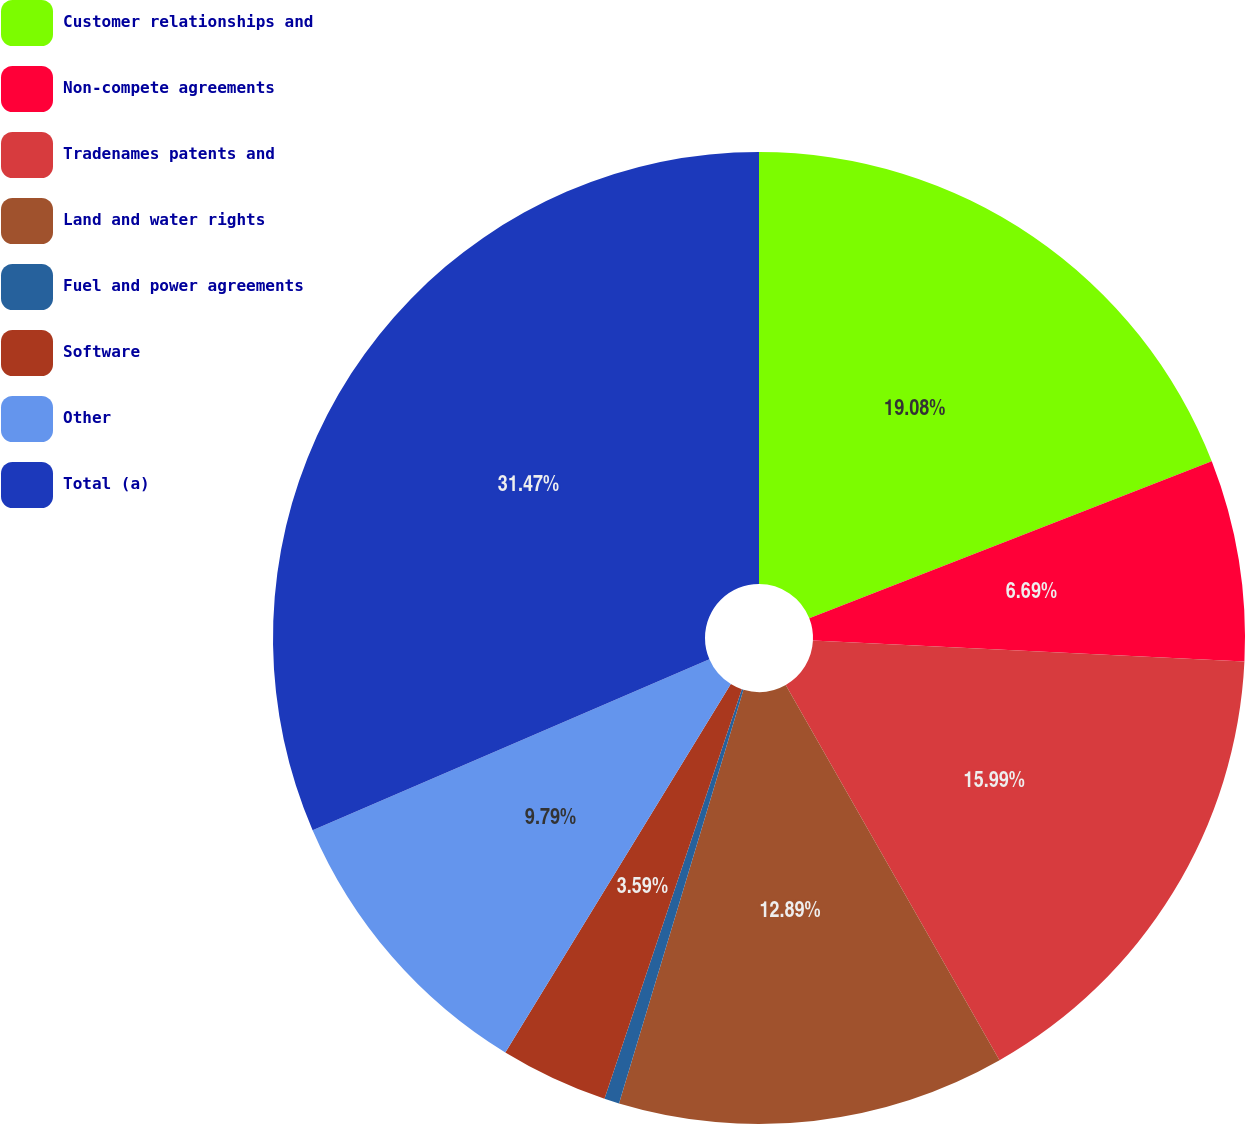<chart> <loc_0><loc_0><loc_500><loc_500><pie_chart><fcel>Customer relationships and<fcel>Non-compete agreements<fcel>Tradenames patents and<fcel>Land and water rights<fcel>Fuel and power agreements<fcel>Software<fcel>Other<fcel>Total (a)<nl><fcel>19.08%<fcel>6.69%<fcel>15.99%<fcel>12.89%<fcel>0.5%<fcel>3.59%<fcel>9.79%<fcel>31.47%<nl></chart> 